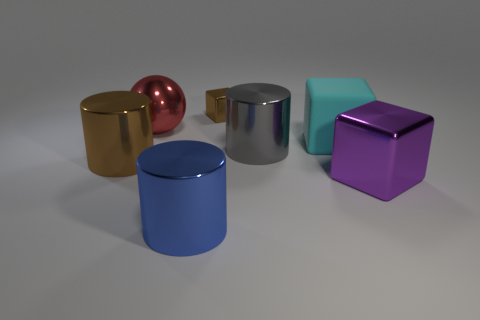Add 1 large yellow matte balls. How many objects exist? 8 Subtract all cylinders. How many objects are left? 4 Add 1 large shiny blocks. How many large shiny blocks are left? 2 Add 7 cyan metallic cylinders. How many cyan metallic cylinders exist? 7 Subtract 0 yellow spheres. How many objects are left? 7 Subtract all cyan matte objects. Subtract all blue metal cylinders. How many objects are left? 5 